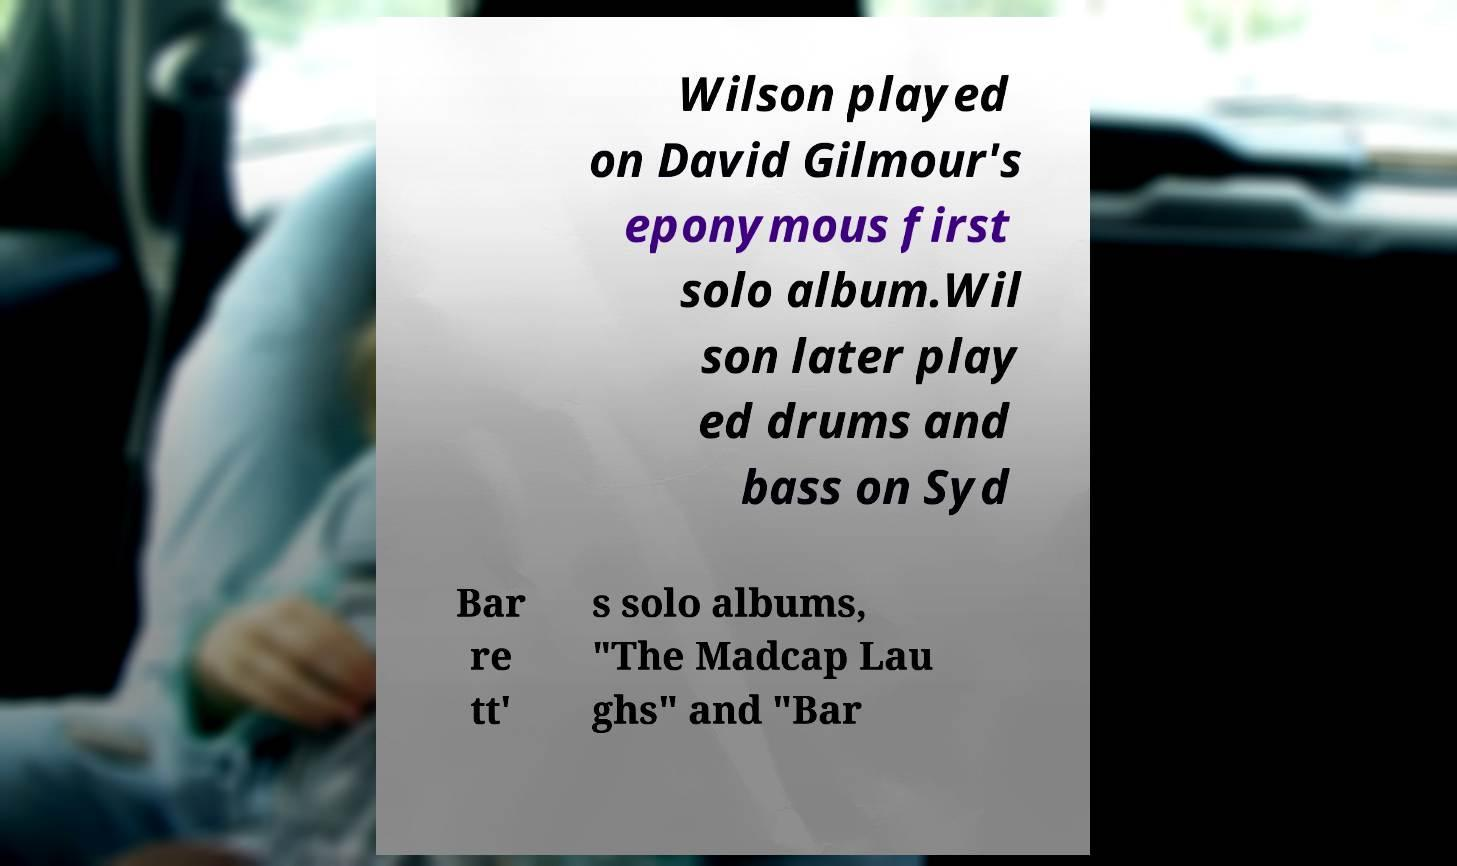Could you extract and type out the text from this image? Wilson played on David Gilmour's eponymous first solo album.Wil son later play ed drums and bass on Syd Bar re tt' s solo albums, "The Madcap Lau ghs" and "Bar 